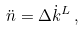<formula> <loc_0><loc_0><loc_500><loc_500>\ddot { n } = \Delta \dot { k } ^ { L } \, ,</formula> 